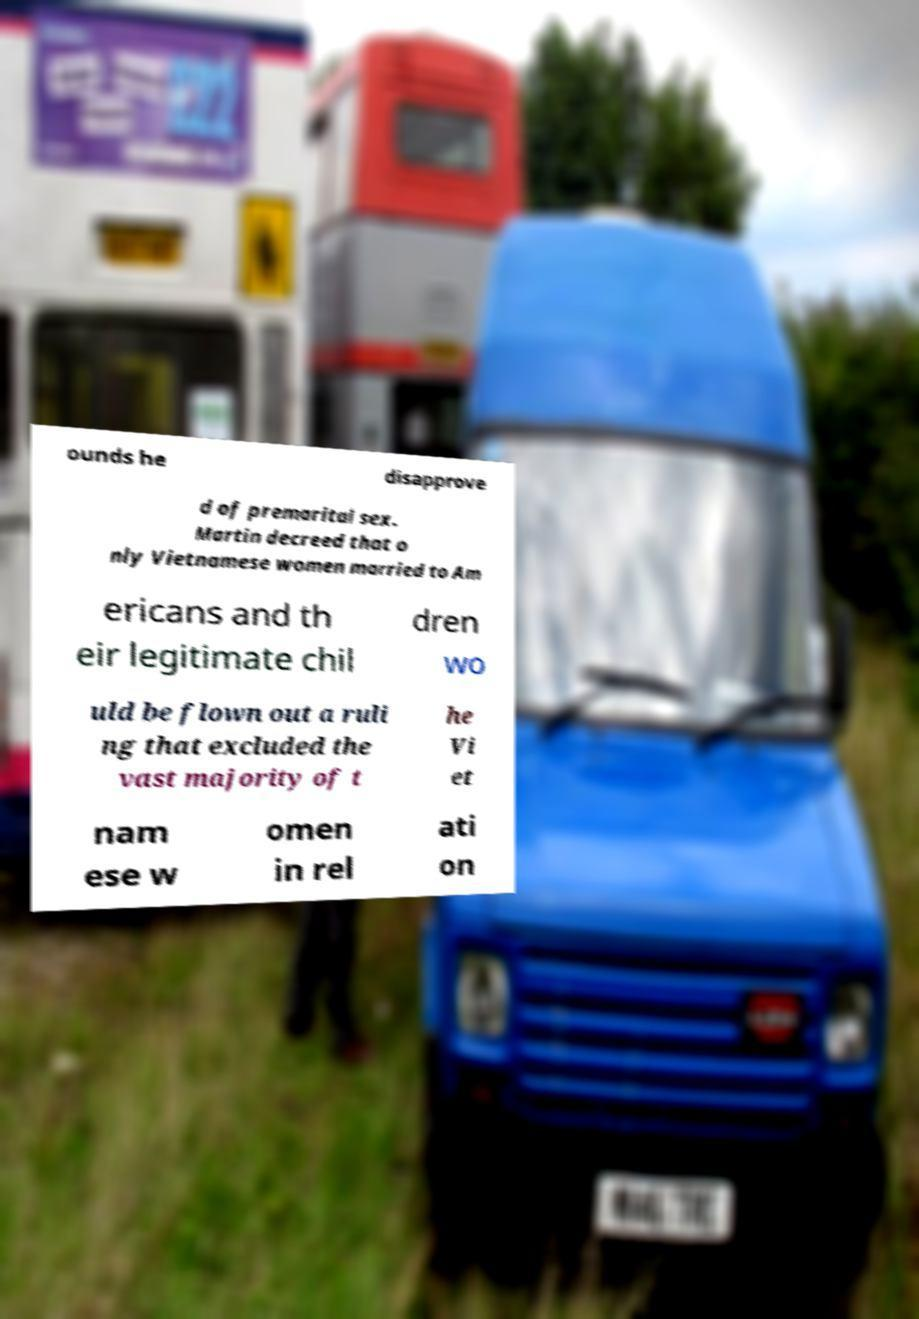What messages or text are displayed in this image? I need them in a readable, typed format. ounds he disapprove d of premarital sex. Martin decreed that o nly Vietnamese women married to Am ericans and th eir legitimate chil dren wo uld be flown out a ruli ng that excluded the vast majority of t he Vi et nam ese w omen in rel ati on 